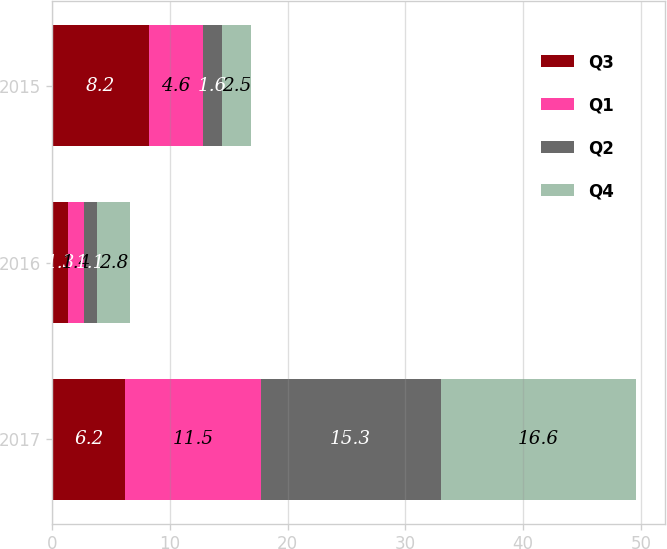<chart> <loc_0><loc_0><loc_500><loc_500><stacked_bar_chart><ecel><fcel>2017<fcel>2016<fcel>2015<nl><fcel>Q3<fcel>6.2<fcel>1.3<fcel>8.2<nl><fcel>Q1<fcel>11.5<fcel>1.4<fcel>4.6<nl><fcel>Q2<fcel>15.3<fcel>1.1<fcel>1.6<nl><fcel>Q4<fcel>16.6<fcel>2.8<fcel>2.5<nl></chart> 